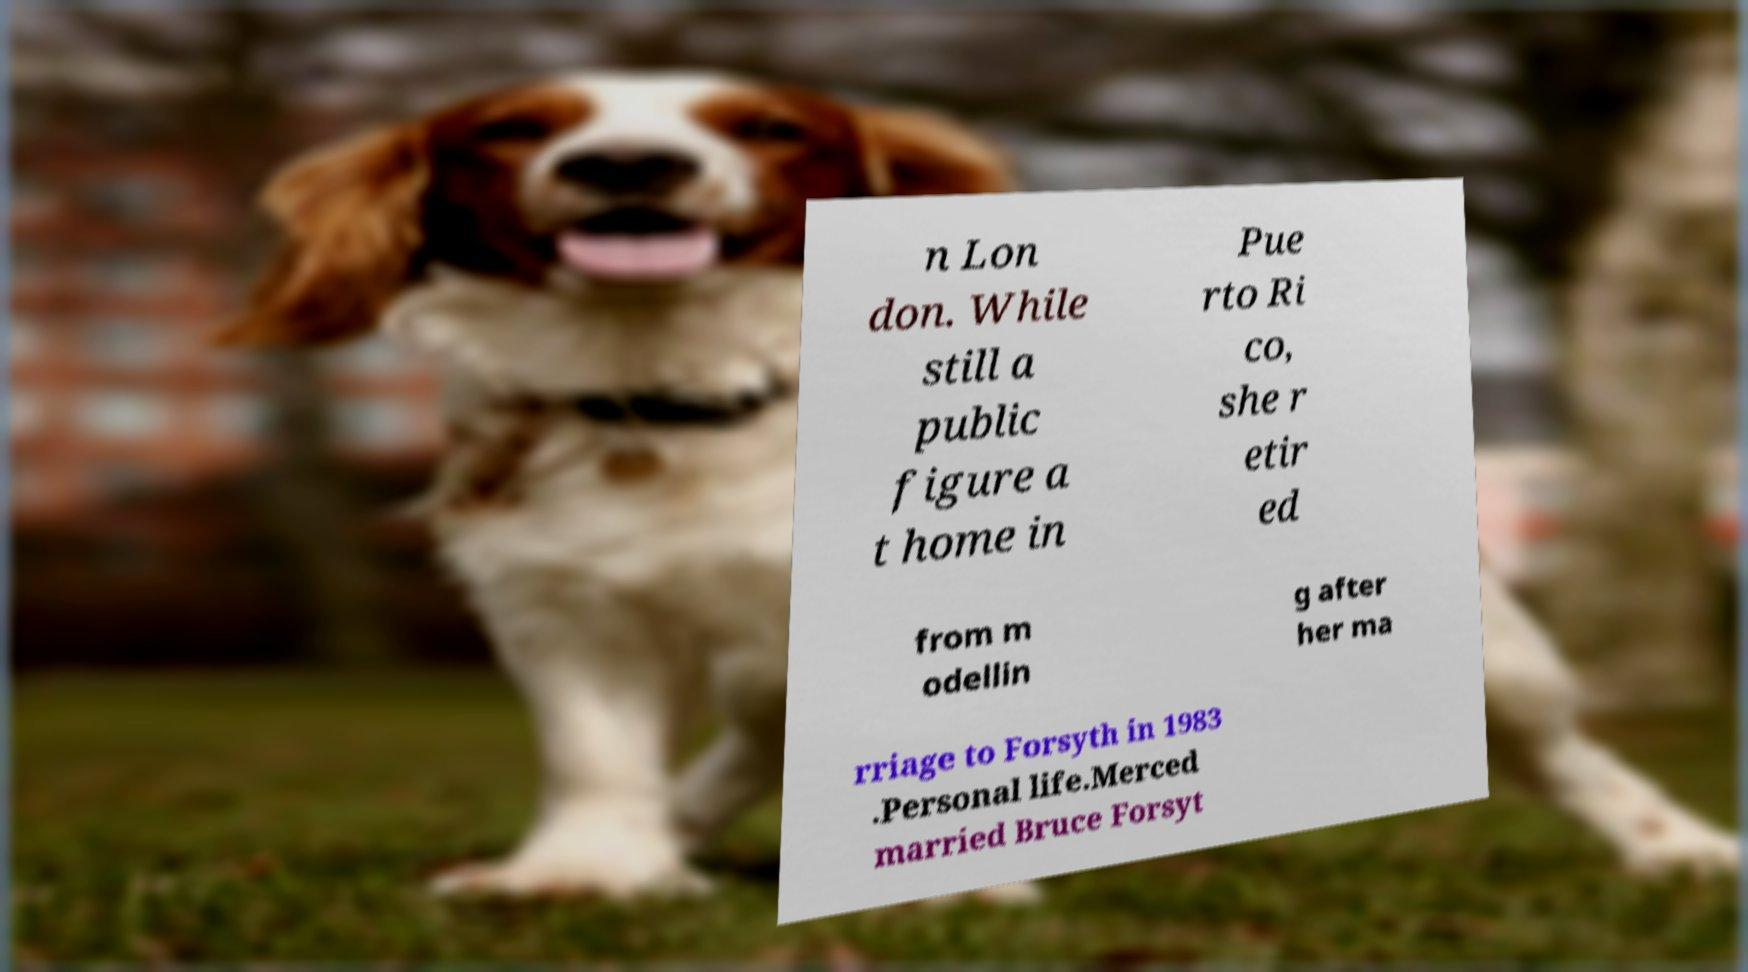What messages or text are displayed in this image? I need them in a readable, typed format. n Lon don. While still a public figure a t home in Pue rto Ri co, she r etir ed from m odellin g after her ma rriage to Forsyth in 1983 .Personal life.Merced married Bruce Forsyt 